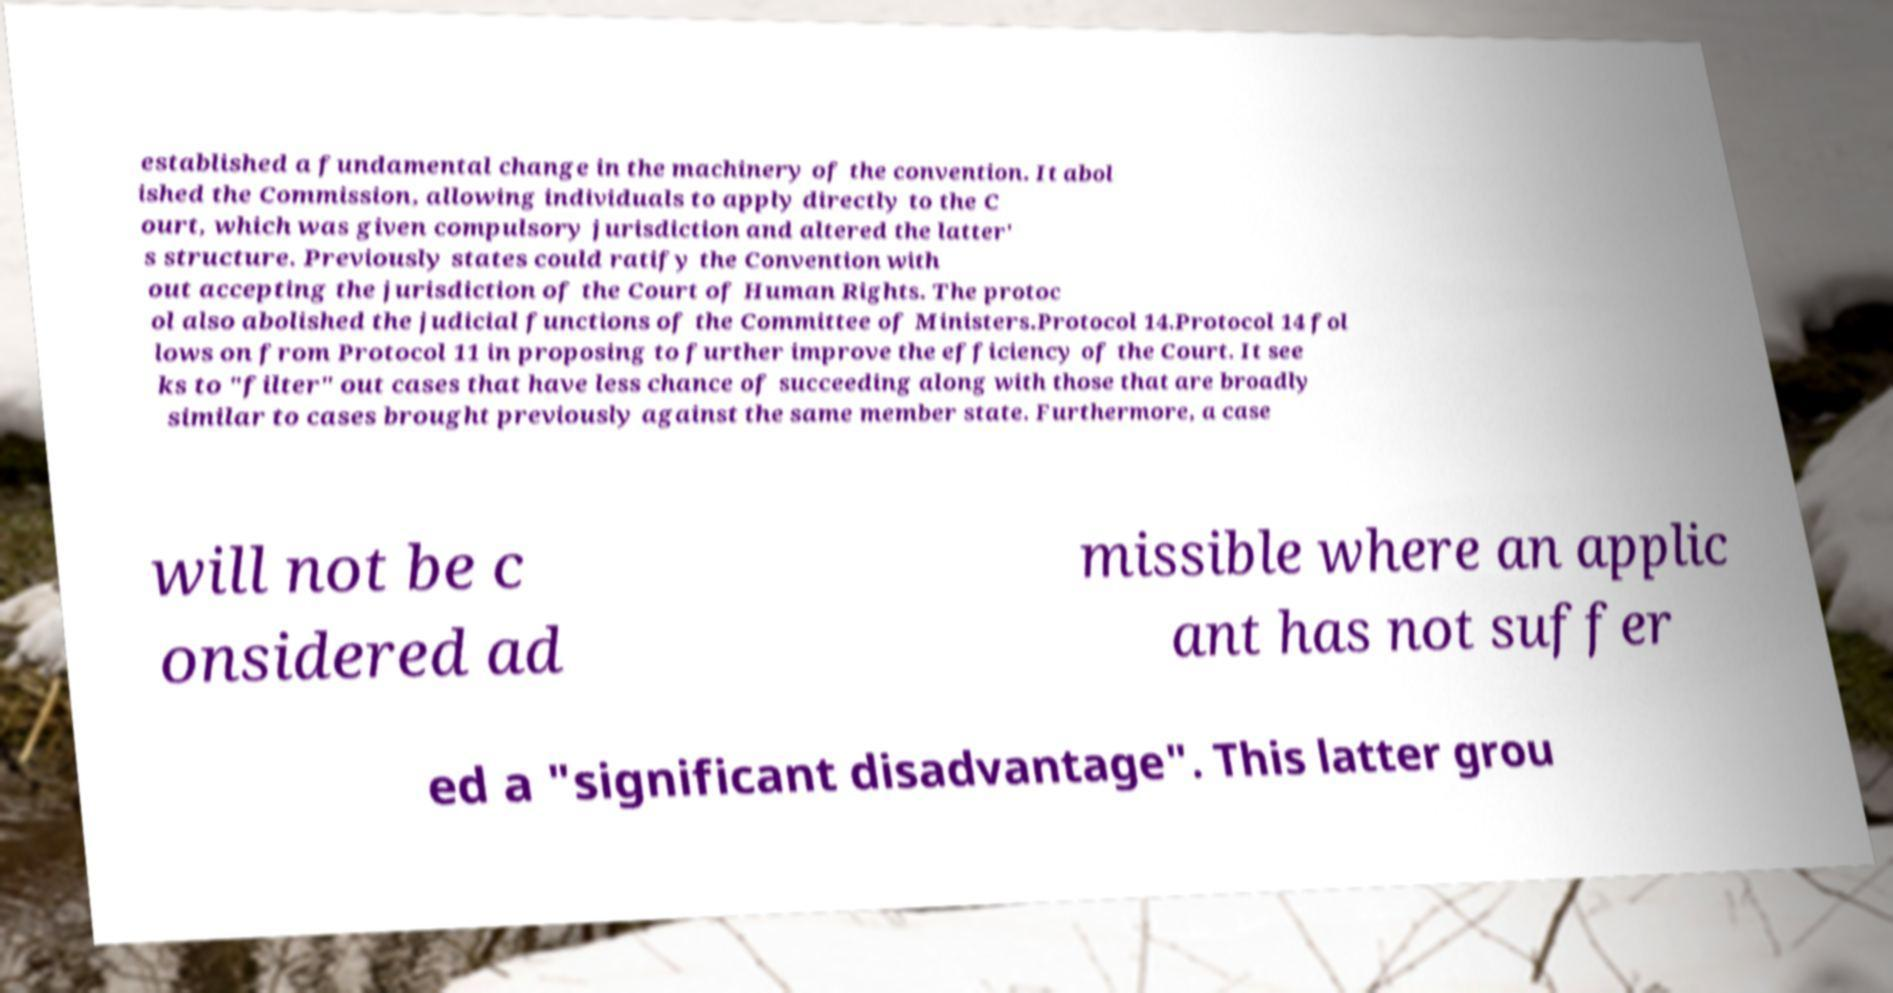Can you read and provide the text displayed in the image?This photo seems to have some interesting text. Can you extract and type it out for me? established a fundamental change in the machinery of the convention. It abol ished the Commission, allowing individuals to apply directly to the C ourt, which was given compulsory jurisdiction and altered the latter' s structure. Previously states could ratify the Convention with out accepting the jurisdiction of the Court of Human Rights. The protoc ol also abolished the judicial functions of the Committee of Ministers.Protocol 14.Protocol 14 fol lows on from Protocol 11 in proposing to further improve the efficiency of the Court. It see ks to "filter" out cases that have less chance of succeeding along with those that are broadly similar to cases brought previously against the same member state. Furthermore, a case will not be c onsidered ad missible where an applic ant has not suffer ed a "significant disadvantage". This latter grou 